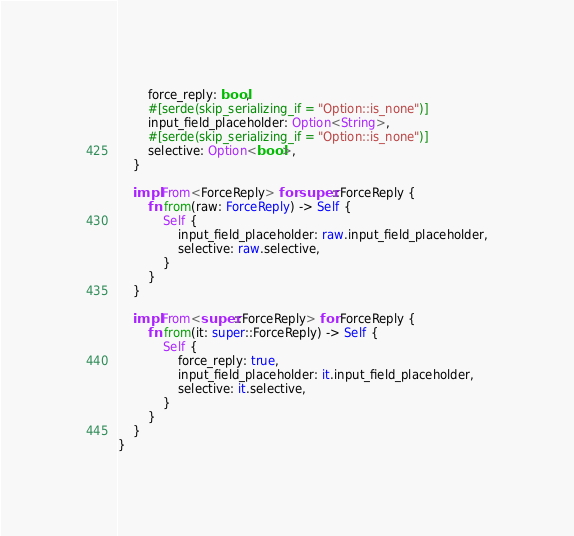Convert code to text. <code><loc_0><loc_0><loc_500><loc_500><_Rust_>        force_reply: bool,
        #[serde(skip_serializing_if = "Option::is_none")]
        input_field_placeholder: Option<String>,
        #[serde(skip_serializing_if = "Option::is_none")]
        selective: Option<bool>,
    }

    impl From<ForceReply> for super::ForceReply {
        fn from(raw: ForceReply) -> Self {
            Self {
                input_field_placeholder: raw.input_field_placeholder,
                selective: raw.selective,
            }
        }
    }

    impl From<super::ForceReply> for ForceReply {
        fn from(it: super::ForceReply) -> Self {
            Self {
                force_reply: true,
                input_field_placeholder: it.input_field_placeholder,
                selective: it.selective,
            }
        }
    }
}
</code> 